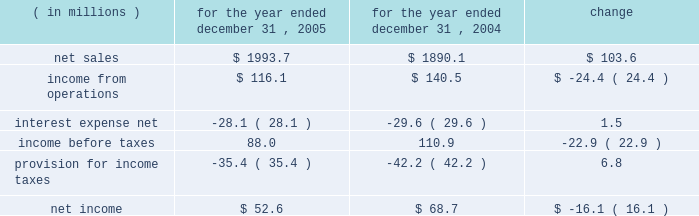Incentive compensation expense ( $ 8.2 million ) and related fringe benefit costs ( $ 1.4 million ) , and higher warehousing costs due to customer requirements ( $ 2.0 million ) .
Corporate overhead for the year ended december 31 , 2006 , increased $ 3.1 million , or 6.5% ( 6.5 % ) , from the year ended december 31 , 2005 .
The increase was primarily attributable to higher incentive compensation expense ( $ 2.6 million ) and other increased costs which were not individually significant .
Other expense , net , decreased $ 2.1 million , or 20.1% ( 20.1 % ) for the year ended december 31 , 2006 compared to the year ended december 31 , 2005 .
The decrease was primarily due to a $ 3.1 million decrease in expenses related to the disposals of property , plant and equipment as part of planned disposals in connection with capital projects .
Partially offsetting the decrease in fixed asset disposal expense was higher legal expenses ( $ 0.5 million ) and increased losses on disposals of storeroom items ( $ 0.4 million ) .
Interest expense , net and income taxes interest expense , net of interest income , increased by $ 3.1 million , or 11.1% ( 11.1 % ) , for the year ended december 31 , 2006 compared to the full year 2005 , primarily as a result of higher interest expense on our variable rate debt due to higher interest rates .
Pca 2019s effective tax rate was 35.8% ( 35.8 % ) for the year ended december 31 , 2006 and 40.2% ( 40.2 % ) for the year ended december 31 , 2005 .
The lower tax rate in 2006 is primarily due to a larger domestic manufacturer 2019s deduction and a reduction in the texas state tax rate .
For both years 2006 and 2005 , tax rates were higher than the federal statutory rate of 35.0% ( 35.0 % ) due to state income taxes .
Year ended december 31 , 2005 compared to year ended december 31 , 2004 the historical results of operations of pca for the years ended december 31 , 2005 and 2004 are set forth below : for the year ended december 31 , ( in millions ) 2005 2004 change .
Net sales net sales increased by $ 103.6 million , or 5.5% ( 5.5 % ) , for the year ended december 31 , 2005 from the year ended december 31 , 2004 .
Net sales increased primarily due to increased sales prices and volumes of corrugated products compared to 2004 .
Total corrugated products volume sold increased 4.2% ( 4.2 % ) to 31.2 billion square feet in 2005 compared to 29.9 billion square feet in 2004 .
On a comparable shipment-per-workday basis , corrugated products sales volume increased 4.6% ( 4.6 % ) in 2005 from 2004 .
Excluding pca 2019s acquisition of midland container in april 2005 , corrugated products volume was 3.0% ( 3.0 % ) higher in 2005 than 2004 and up 3.4% ( 3.4 % ) compared to 2004 on a shipment-per-workday basis .
Shipments-per-workday is calculated by dividing our total corrugated products volume during the year by the number of workdays within the year .
The larger percentage increase was due to the fact that 2005 had one less workday ( 250 days ) , those days not falling on a weekend or holiday , than 2004 ( 251 days ) .
Containerboard sales volume to external domestic and export customers decreased 12.2% ( 12.2 % ) to 417000 tons for the year ended december 31 , 2005 from 475000 tons in 2004. .
Pca 2019s effective tax rate decreased by how many percentage points for the year ended december 31 , 2006 compared to the year ended december 31 , 2005? 
Computations: (40.2 - 35.8)
Answer: 4.4. 